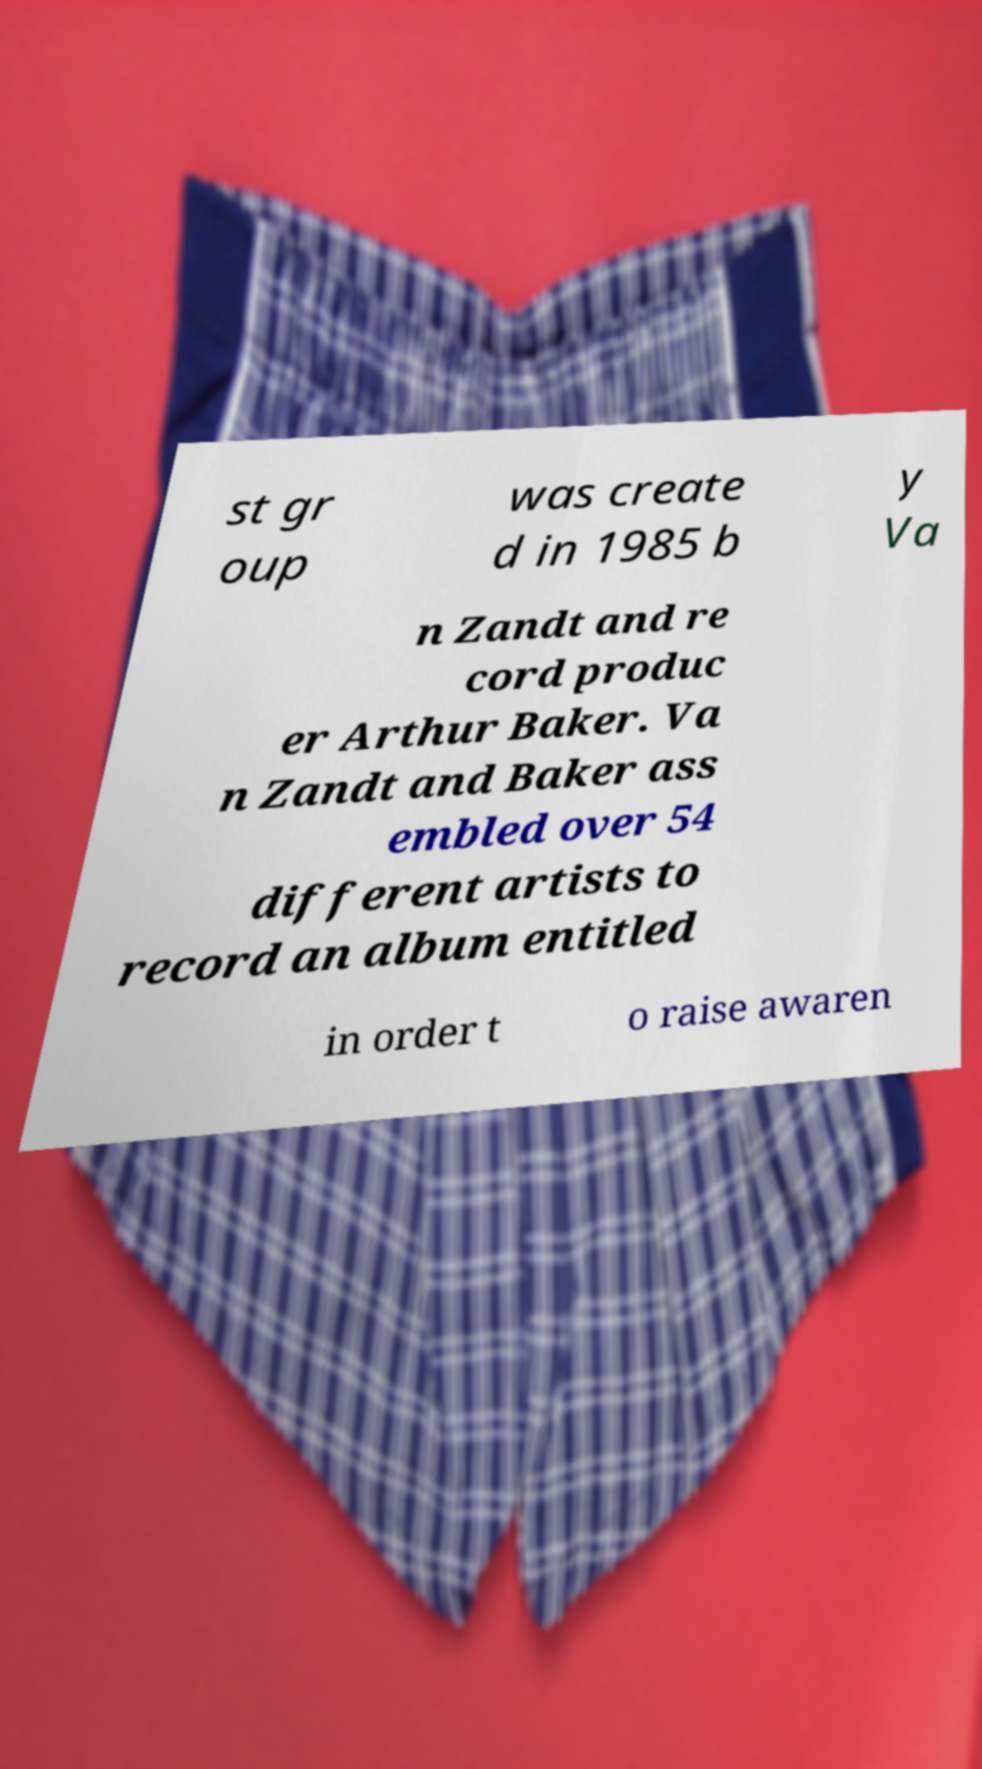There's text embedded in this image that I need extracted. Can you transcribe it verbatim? st gr oup was create d in 1985 b y Va n Zandt and re cord produc er Arthur Baker. Va n Zandt and Baker ass embled over 54 different artists to record an album entitled in order t o raise awaren 